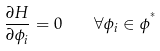Convert formula to latex. <formula><loc_0><loc_0><loc_500><loc_500>\frac { \partial H } { \partial \phi _ { i } } = 0 \quad \forall \phi _ { i } \in \phi ^ { ^ { * } }</formula> 